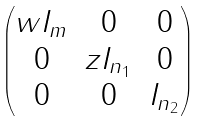<formula> <loc_0><loc_0><loc_500><loc_500>\begin{pmatrix} w I _ { m } & 0 & 0 \\ 0 & z I _ { n _ { 1 } } & 0 \\ 0 & 0 & I _ { n _ { 2 } } \end{pmatrix}</formula> 